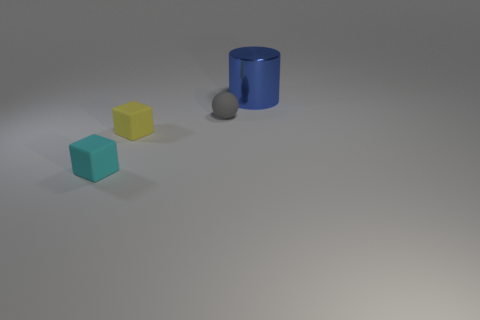Subtract 1 balls. How many balls are left? 0 Add 1 small yellow matte cubes. How many objects exist? 5 Add 2 small spheres. How many small spheres exist? 3 Subtract 0 green cubes. How many objects are left? 4 Subtract all purple blocks. Subtract all yellow spheres. How many blocks are left? 2 Subtract all yellow blocks. How many cyan cylinders are left? 0 Subtract all small yellow things. Subtract all tiny yellow matte things. How many objects are left? 2 Add 3 large metal cylinders. How many large metal cylinders are left? 4 